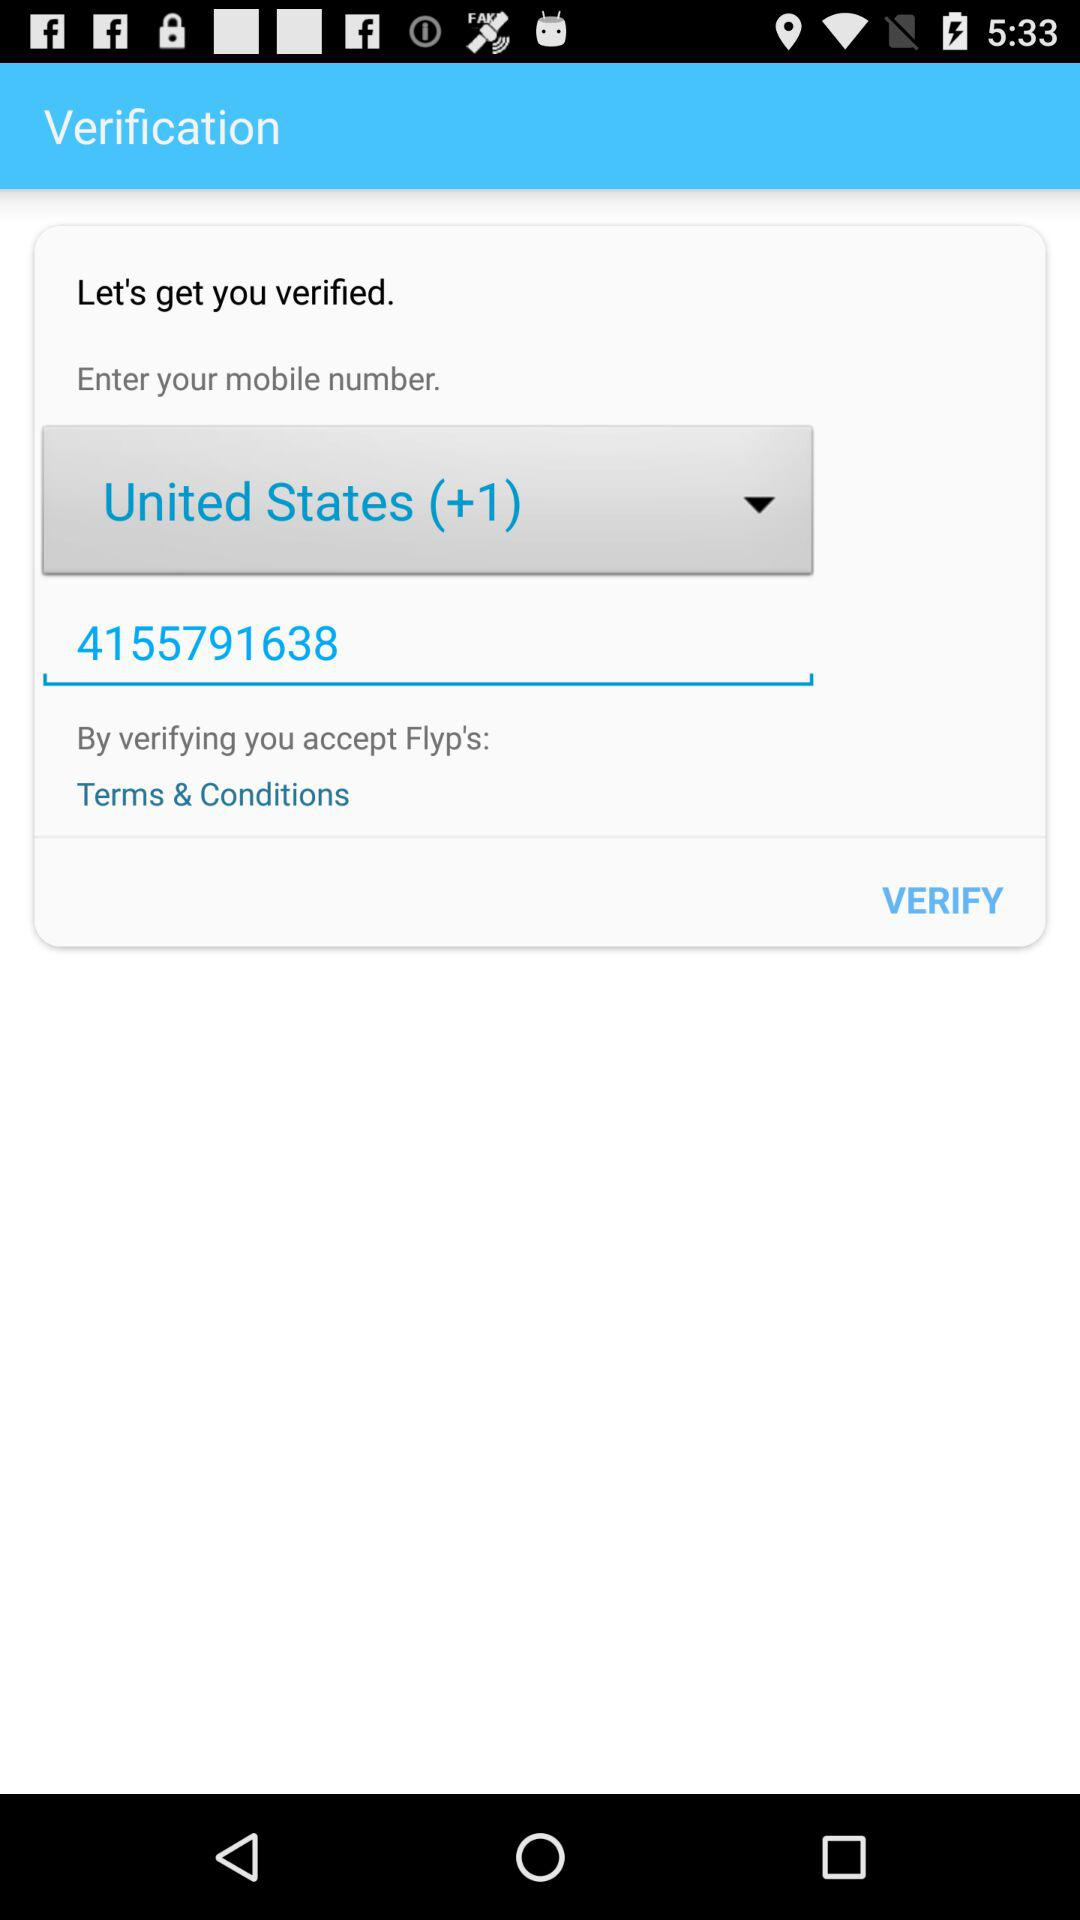Who is getting verified?
When the provided information is insufficient, respond with <no answer>. <no answer> 